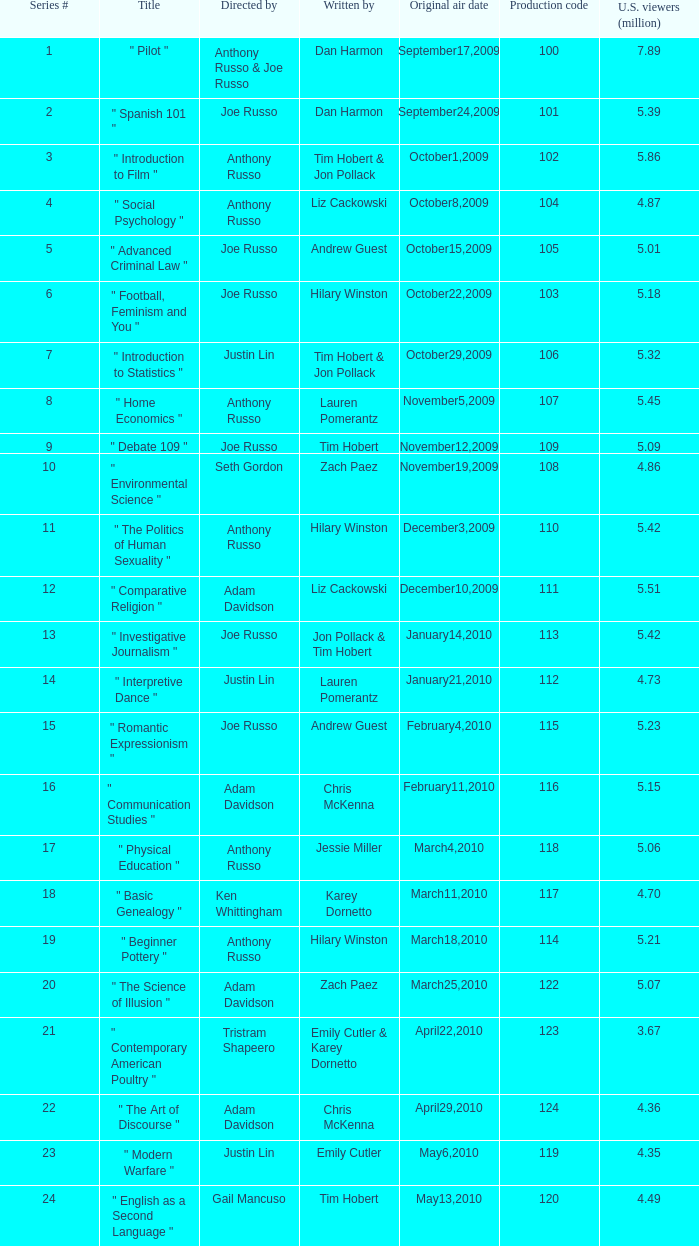On which date did the original airing attract 5.39 million viewers in the u.s.? September24,2009. 